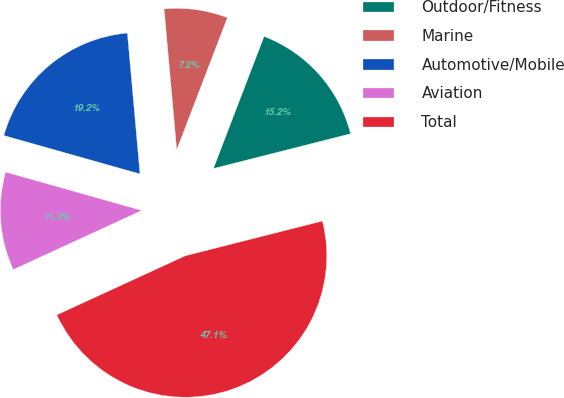Convert chart to OTSL. <chart><loc_0><loc_0><loc_500><loc_500><pie_chart><fcel>Outdoor/Fitness<fcel>Marine<fcel>Automotive/Mobile<fcel>Aviation<fcel>Total<nl><fcel>15.22%<fcel>7.25%<fcel>19.2%<fcel>11.24%<fcel>47.09%<nl></chart> 